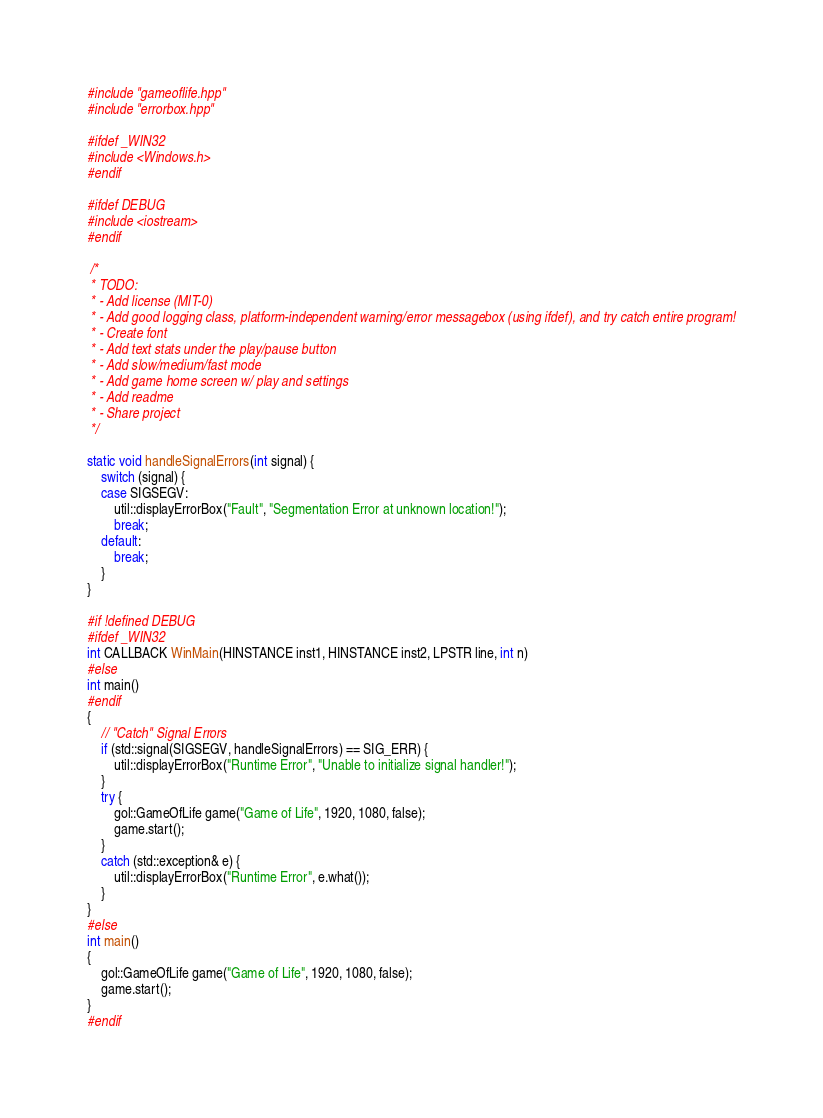<code> <loc_0><loc_0><loc_500><loc_500><_C++_>#include "gameoflife.hpp"
#include "errorbox.hpp"

#ifdef _WIN32
#include <Windows.h>
#endif

#ifdef DEBUG
#include <iostream>
#endif

 /*
 * TODO:
 * - Add license (MIT-0)
 * - Add good logging class, platform-independent warning/error messagebox (using ifdef), and try catch entire program!
 * - Create font
 * - Add text stats under the play/pause button
 * - Add slow/medium/fast mode
 * - Add game home screen w/ play and settings
 * - Add readme
 * - Share project
 */

static void handleSignalErrors(int signal) {
	switch (signal) {
	case SIGSEGV:
		util::displayErrorBox("Fault", "Segmentation Error at unknown location!");
		break;
	default:
		break;
	}
}

#if !defined DEBUG
#ifdef _WIN32
int CALLBACK WinMain(HINSTANCE inst1, HINSTANCE inst2, LPSTR line, int n)
#else
int main()
#endif
{
	// "Catch" Signal Errors
	if (std::signal(SIGSEGV, handleSignalErrors) == SIG_ERR) {
		util::displayErrorBox("Runtime Error", "Unable to initialize signal handler!");
	}
	try {
		gol::GameOfLife game("Game of Life", 1920, 1080, false);
		game.start();
	}
	catch (std::exception& e) {
		util::displayErrorBox("Runtime Error", e.what());
	}
}
#else
int main()
{
	gol::GameOfLife game("Game of Life", 1920, 1080, false);
	game.start();
}
#endif
</code> 